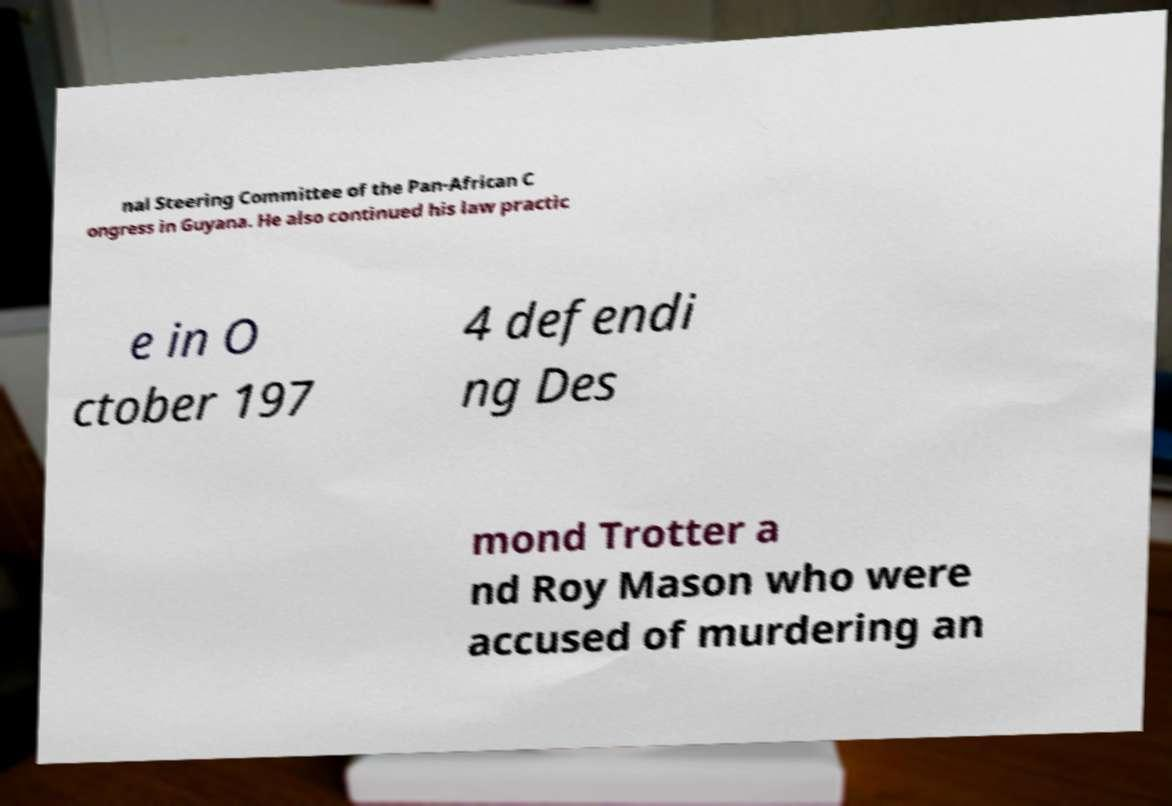Please identify and transcribe the text found in this image. nal Steering Committee of the Pan-African C ongress in Guyana. He also continued his law practic e in O ctober 197 4 defendi ng Des mond Trotter a nd Roy Mason who were accused of murdering an 